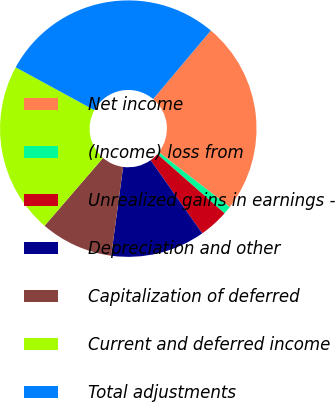Convert chart. <chart><loc_0><loc_0><loc_500><loc_500><pie_chart><fcel>Net income<fcel>(Income) loss from<fcel>Unrealized gains in earnings -<fcel>Depreciation and other<fcel>Capitalization of deferred<fcel>Current and deferred income<fcel>Total adjustments<nl><fcel>24.34%<fcel>1.01%<fcel>3.73%<fcel>11.91%<fcel>9.19%<fcel>21.62%<fcel>28.19%<nl></chart> 